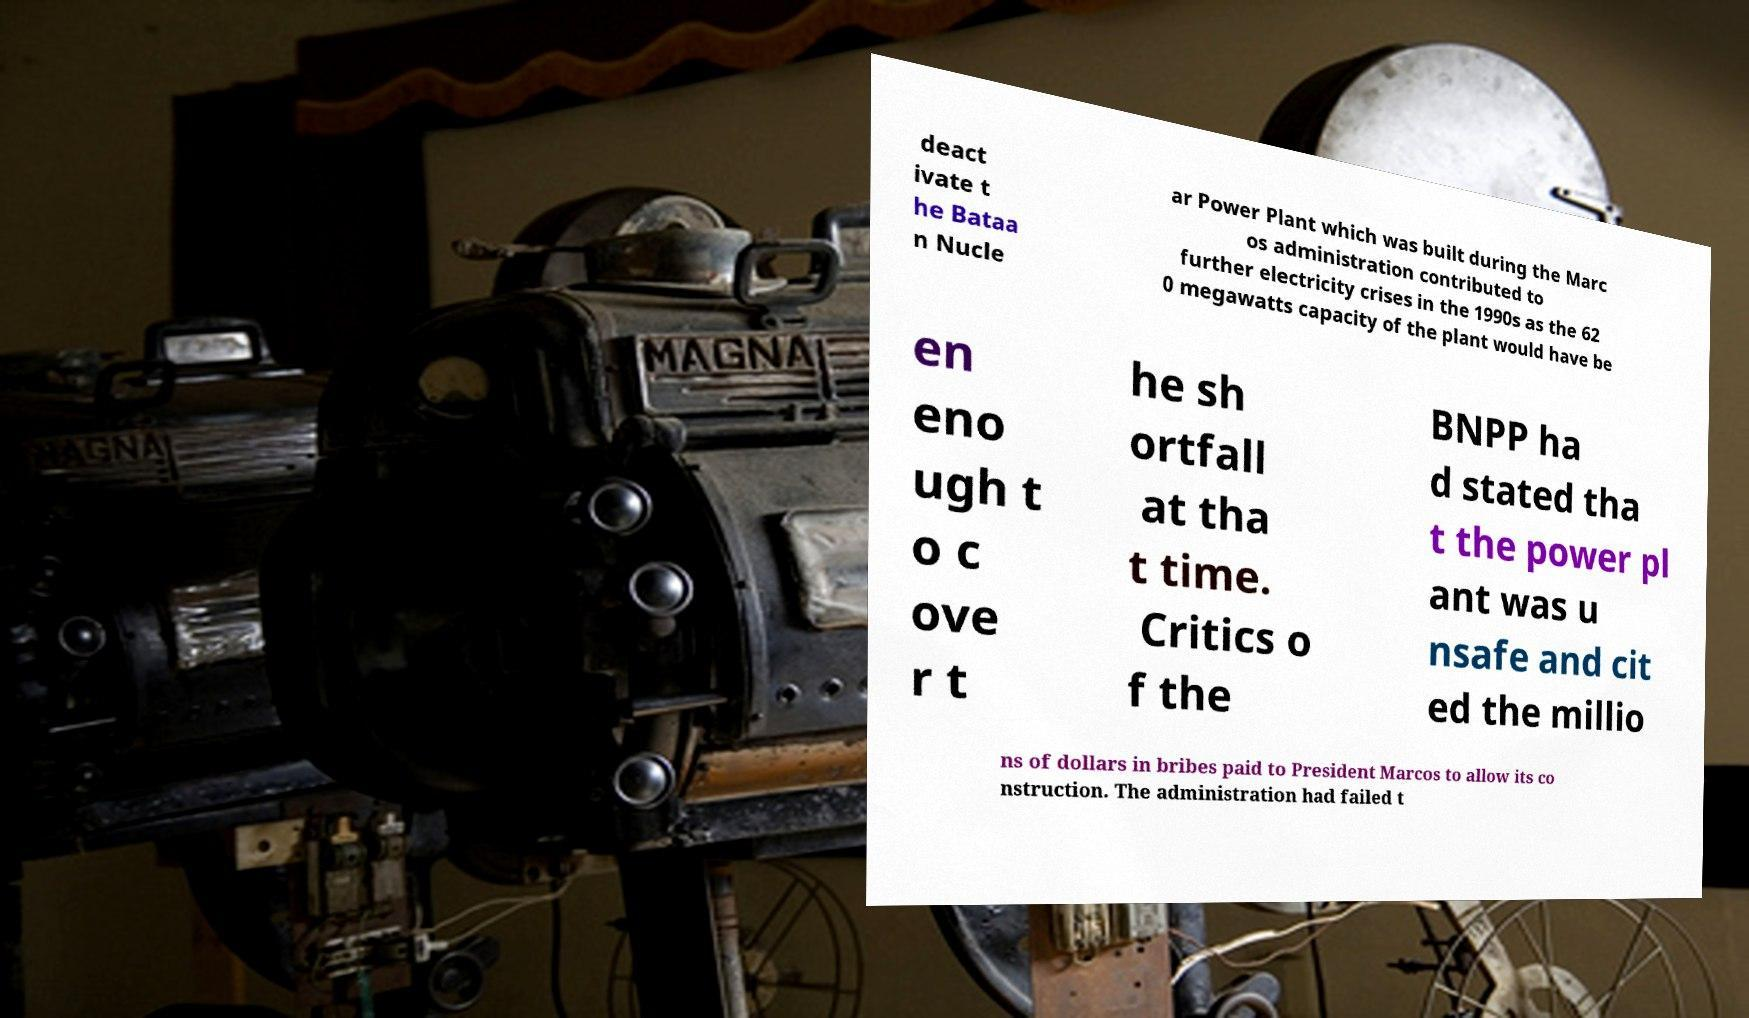Could you extract and type out the text from this image? deact ivate t he Bataa n Nucle ar Power Plant which was built during the Marc os administration contributed to further electricity crises in the 1990s as the 62 0 megawatts capacity of the plant would have be en eno ugh t o c ove r t he sh ortfall at tha t time. Critics o f the BNPP ha d stated tha t the power pl ant was u nsafe and cit ed the millio ns of dollars in bribes paid to President Marcos to allow its co nstruction. The administration had failed t 